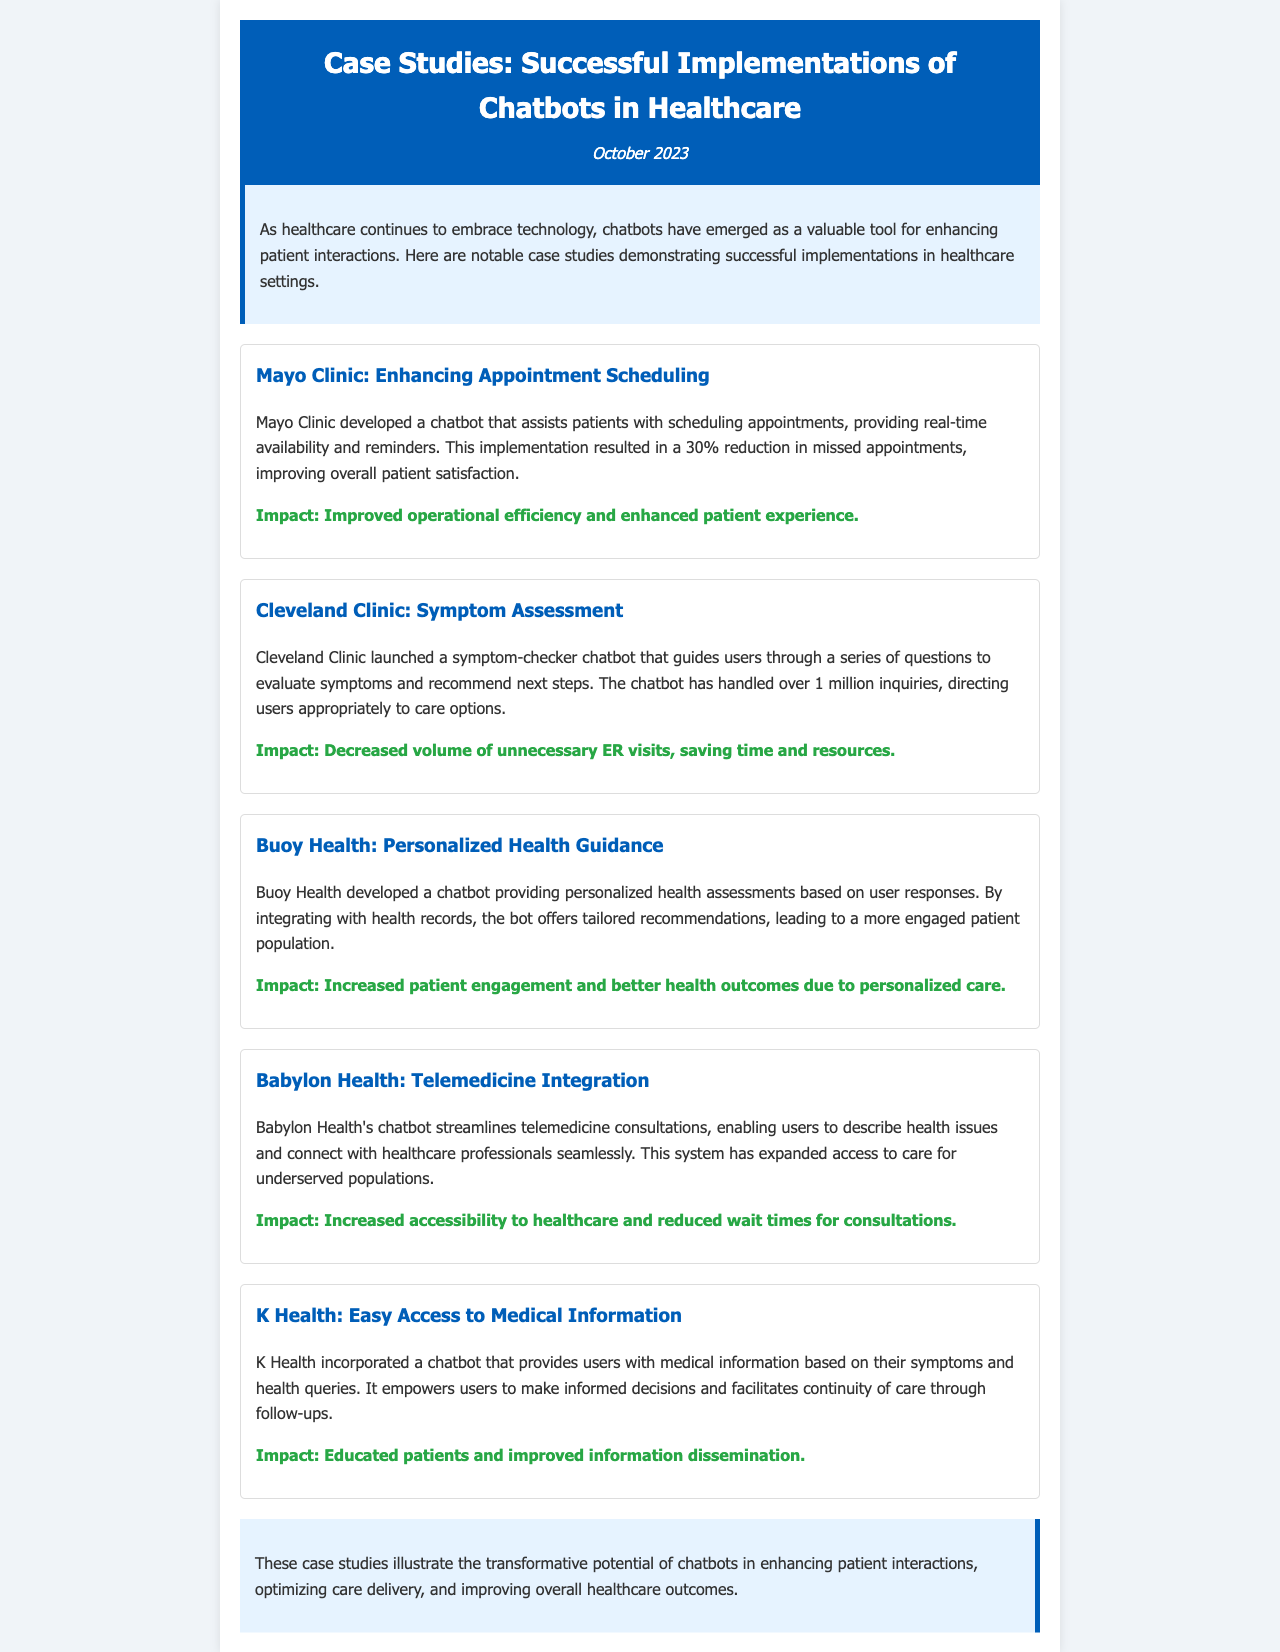What is the title of the newsletter? The title is prominently displayed at the top of the document as the main header.
Answer: Case Studies: Successful Implementations of Chatbots in Healthcare What month and year is the newsletter published? The publication date is mentioned just below the title in the header section.
Answer: October 2023 How many inquiries has the Cleveland Clinic's chatbot handled? The document specifies the number of inquiries handled by the chatbot in the Cleveland Clinic case study section.
Answer: over 1 million What percentage reduction in missed appointments did the Mayo Clinic achieve? The percentage is specifically mentioned in the Mayo Clinic case study, highlighting the effectiveness of their chatbot.
Answer: 30% Which healthcare company developed the chatbot for personalized health guidance? The company responsible for creating the personalized health guidance chatbot is stated in the respective case study.
Answer: Buoy Health What is the primary impact mentioned for Babylon Health's chatbot? The impact of the chatbot is detailed in the case study focused on Babylon Health.
Answer: Increased accessibility to healthcare What type of chatbot did K Health incorporate? The specific purpose of the chatbot implemented by K Health is noted in its case study.
Answer: Medical information What does the conclusion emphasize about chatbots in healthcare? The conclusion summarizes the overall potential and benefits of chatbots in the context of healthcare.
Answer: Transformative potential 